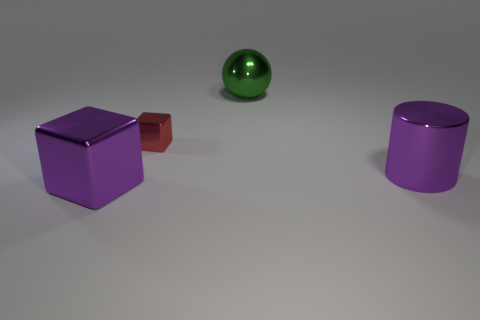What number of other objects are there of the same material as the purple cube? 3 